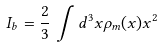Convert formula to latex. <formula><loc_0><loc_0><loc_500><loc_500>I _ { b } = \frac { 2 } { 3 } \, \int d ^ { 3 } x \rho _ { m } ( x ) x ^ { 2 }</formula> 